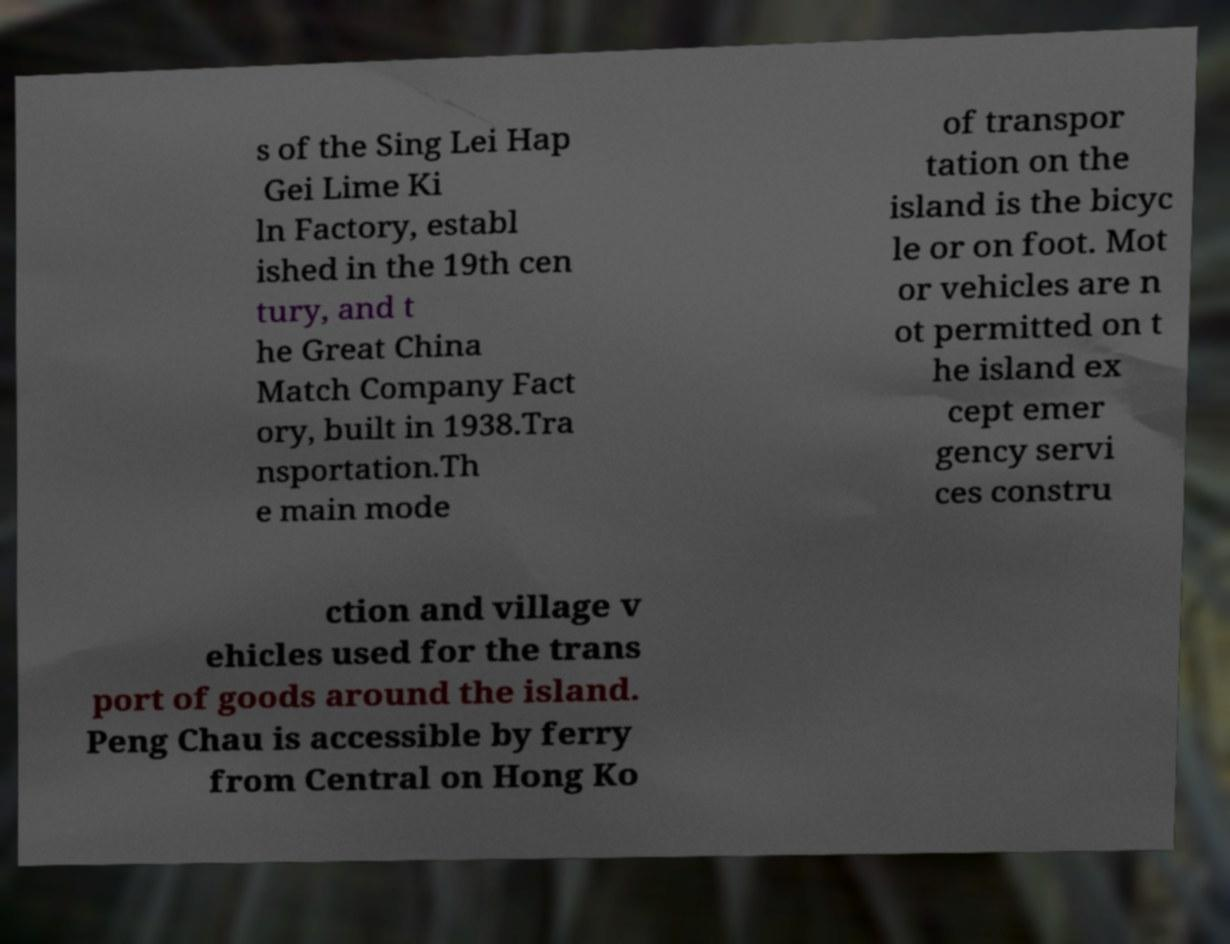For documentation purposes, I need the text within this image transcribed. Could you provide that? s of the Sing Lei Hap Gei Lime Ki ln Factory, establ ished in the 19th cen tury, and t he Great China Match Company Fact ory, built in 1938.Tra nsportation.Th e main mode of transpor tation on the island is the bicyc le or on foot. Mot or vehicles are n ot permitted on t he island ex cept emer gency servi ces constru ction and village v ehicles used for the trans port of goods around the island. Peng Chau is accessible by ferry from Central on Hong Ko 